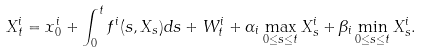Convert formula to latex. <formula><loc_0><loc_0><loc_500><loc_500>X _ { t } ^ { i } = x _ { 0 } ^ { i } + \int _ { 0 } ^ { t } f ^ { i } ( s , X _ { s } ) d s + W _ { t } ^ { i } + \alpha _ { i } \max _ { 0 \leq s \leq t } X ^ { i } _ { s } + \beta _ { i } \min _ { 0 \leq s \leq t } X ^ { i } _ { s } .</formula> 